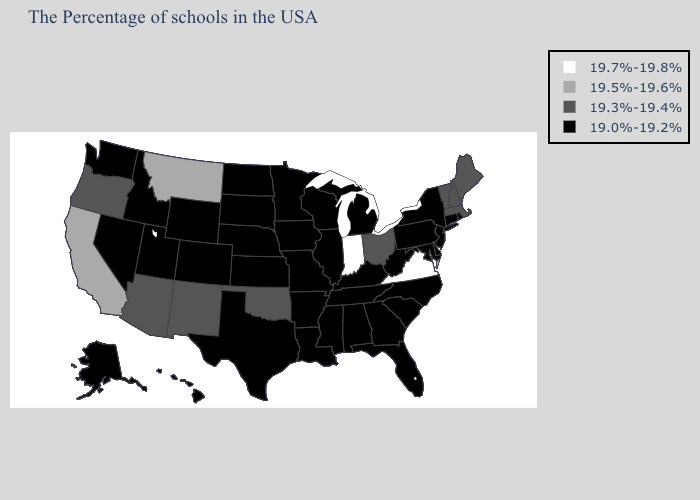Is the legend a continuous bar?
Quick response, please. No. Does the first symbol in the legend represent the smallest category?
Write a very short answer. No. Name the states that have a value in the range 19.0%-19.2%?
Give a very brief answer. Rhode Island, Connecticut, New York, New Jersey, Delaware, Maryland, Pennsylvania, North Carolina, South Carolina, West Virginia, Florida, Georgia, Michigan, Kentucky, Alabama, Tennessee, Wisconsin, Illinois, Mississippi, Louisiana, Missouri, Arkansas, Minnesota, Iowa, Kansas, Nebraska, Texas, South Dakota, North Dakota, Wyoming, Colorado, Utah, Idaho, Nevada, Washington, Alaska, Hawaii. Name the states that have a value in the range 19.3%-19.4%?
Short answer required. Maine, Massachusetts, New Hampshire, Vermont, Ohio, Oklahoma, New Mexico, Arizona, Oregon. Which states have the highest value in the USA?
Give a very brief answer. Virginia, Indiana. Does Utah have the highest value in the West?
Be succinct. No. Does Alaska have the lowest value in the West?
Concise answer only. Yes. Name the states that have a value in the range 19.7%-19.8%?
Answer briefly. Virginia, Indiana. Name the states that have a value in the range 19.7%-19.8%?
Keep it brief. Virginia, Indiana. What is the value of Idaho?
Quick response, please. 19.0%-19.2%. Among the states that border Missouri , which have the highest value?
Give a very brief answer. Oklahoma. Name the states that have a value in the range 19.3%-19.4%?
Concise answer only. Maine, Massachusetts, New Hampshire, Vermont, Ohio, Oklahoma, New Mexico, Arizona, Oregon. Does Michigan have a lower value than West Virginia?
Be succinct. No. Among the states that border Missouri , does Oklahoma have the highest value?
Short answer required. Yes. What is the lowest value in the USA?
Quick response, please. 19.0%-19.2%. 